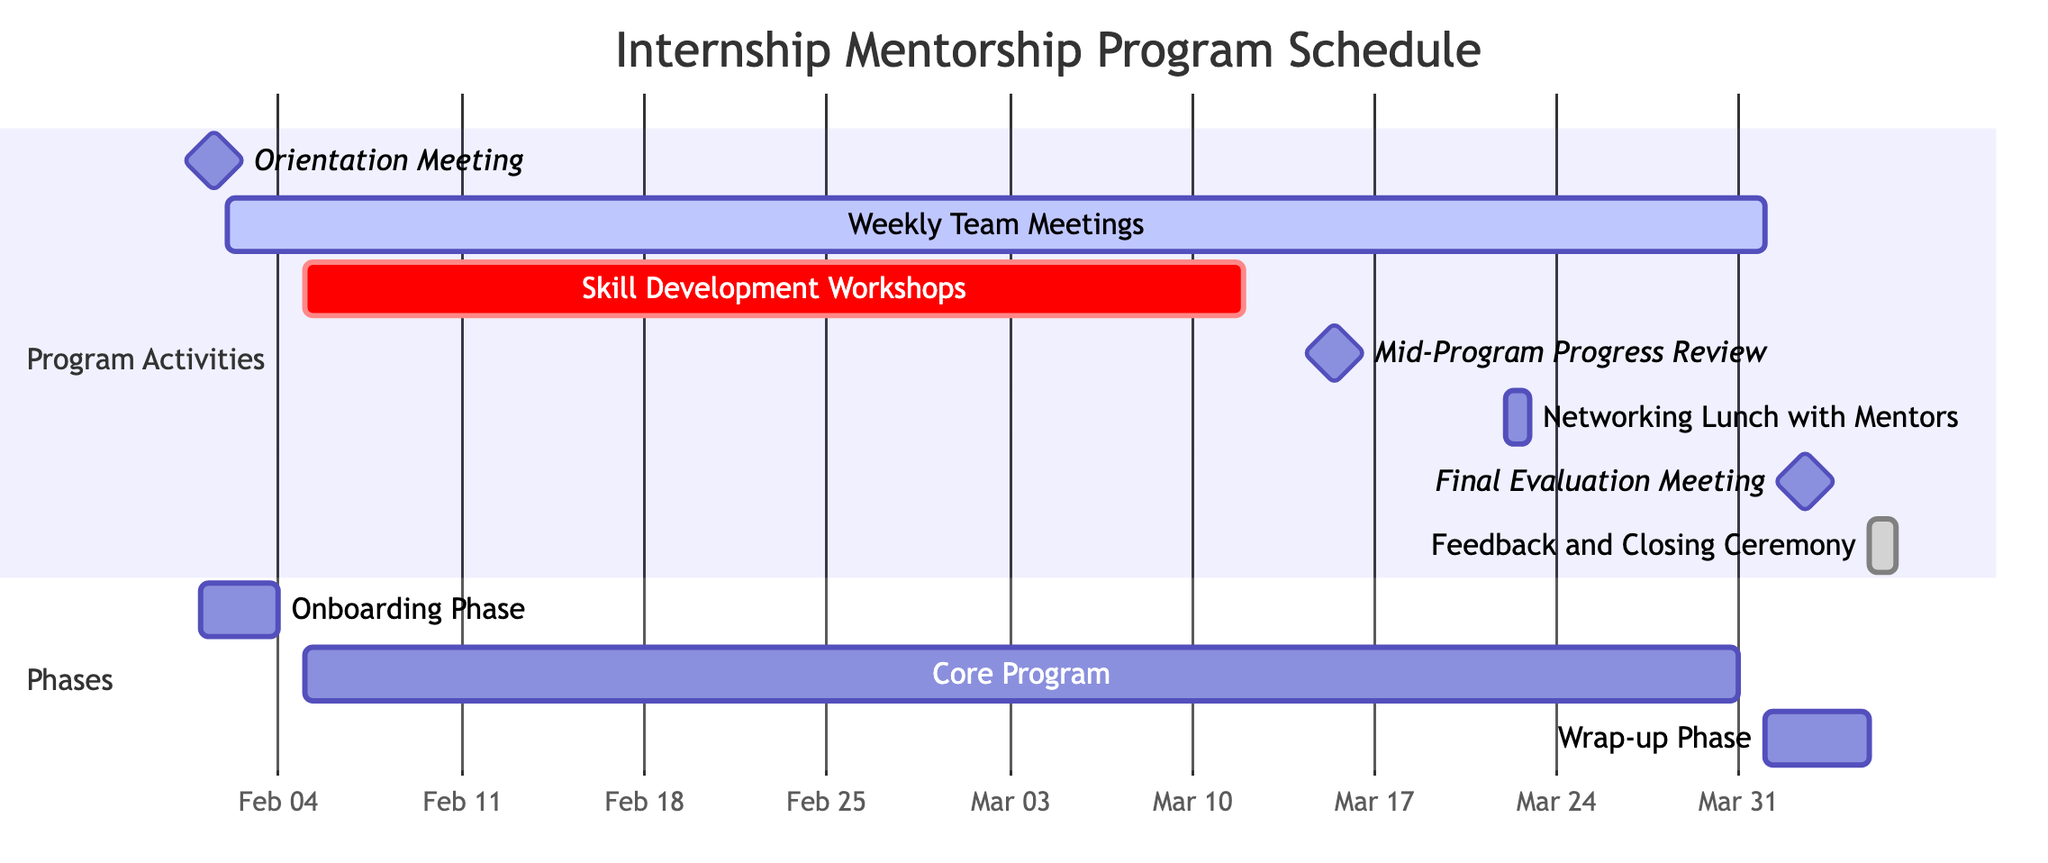What is the duration of the Skill Development Workshops? The Skill Development Workshops span from February 5 to March 12, which is a total of 6 weeks, as indicated by the labeled duration next to the activity.
Answer: 6 weeks When is the Mid-Program Progress Review scheduled? The Mid-Program Progress Review is scheduled for March 15, as shown in the diagram where this activity is marked with its specific start date and designated as a milestone.
Answer: March 15 How many days are allocated for the Orientation Meeting? The Orientation Meeting is indicated as a milestone that lasts for 1 day on February 1, hence the duration is explicitly shown next to this activity.
Answer: 1 day What is the last activity in the Gantt Chart? The last activity in the Gantt Chart is the Feedback and Closing Ceremony, which occurs on April 5, as determined by the list of activities and their respective dates.
Answer: Feedback and Closing Ceremony Which activity overlaps with the Weekly Team Meetings? The Skill Development Workshops overlap with the Weekly Team Meetings, starting on February 5 and ending on March 12, while the Weekly Team Meetings cover a period from February 2 to April 1. This requires a check of the date ranges for both activities.
Answer: Skill Development Workshops How many total activities are represented in the Gantt Chart? There are 7 activities represented in the Gantt Chart, which can be counted by reviewing each listed activity under the Program Activities section.
Answer: 7 activities What phase includes the Final Evaluation Meeting? The Final Evaluation Meeting, scheduled for April 2, is part of the Wrap-up Phase, which runs from April 1 to April 5 as per the identified date ranges in the phases section of the diagram.
Answer: Wrap-up Phase 